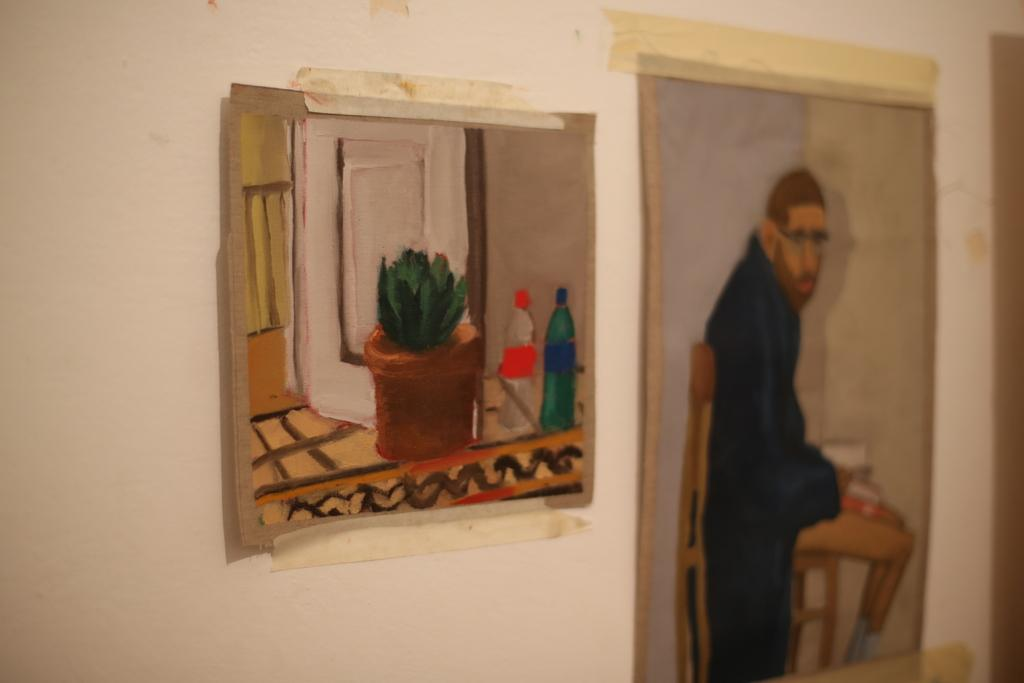What is on the boards that are visible in the image? There is a painting on the boards. Where are the boards located in the image? The boards are placed on a wall. How many bikes are parked next to the painting on the boards? There are no bikes visible in the image; it only shows a painting on the boards placed on a wall. 